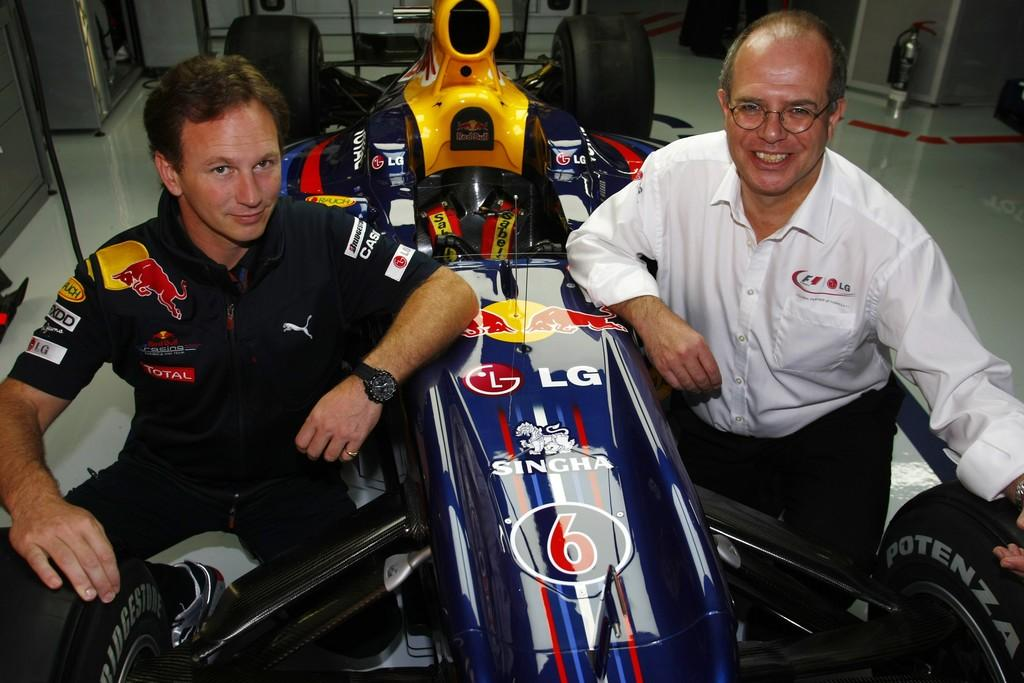How many people are in the image? There are two people in the foreground of the image. What is the main subject in the image? There is an F1 racing car in the image. Can you describe anything visible in the top right corner of the image? There is a spray visible in the top right corner of the image. What type of shoes are the people wearing in the image? There is no information about the shoes the people are wearing in the image. 